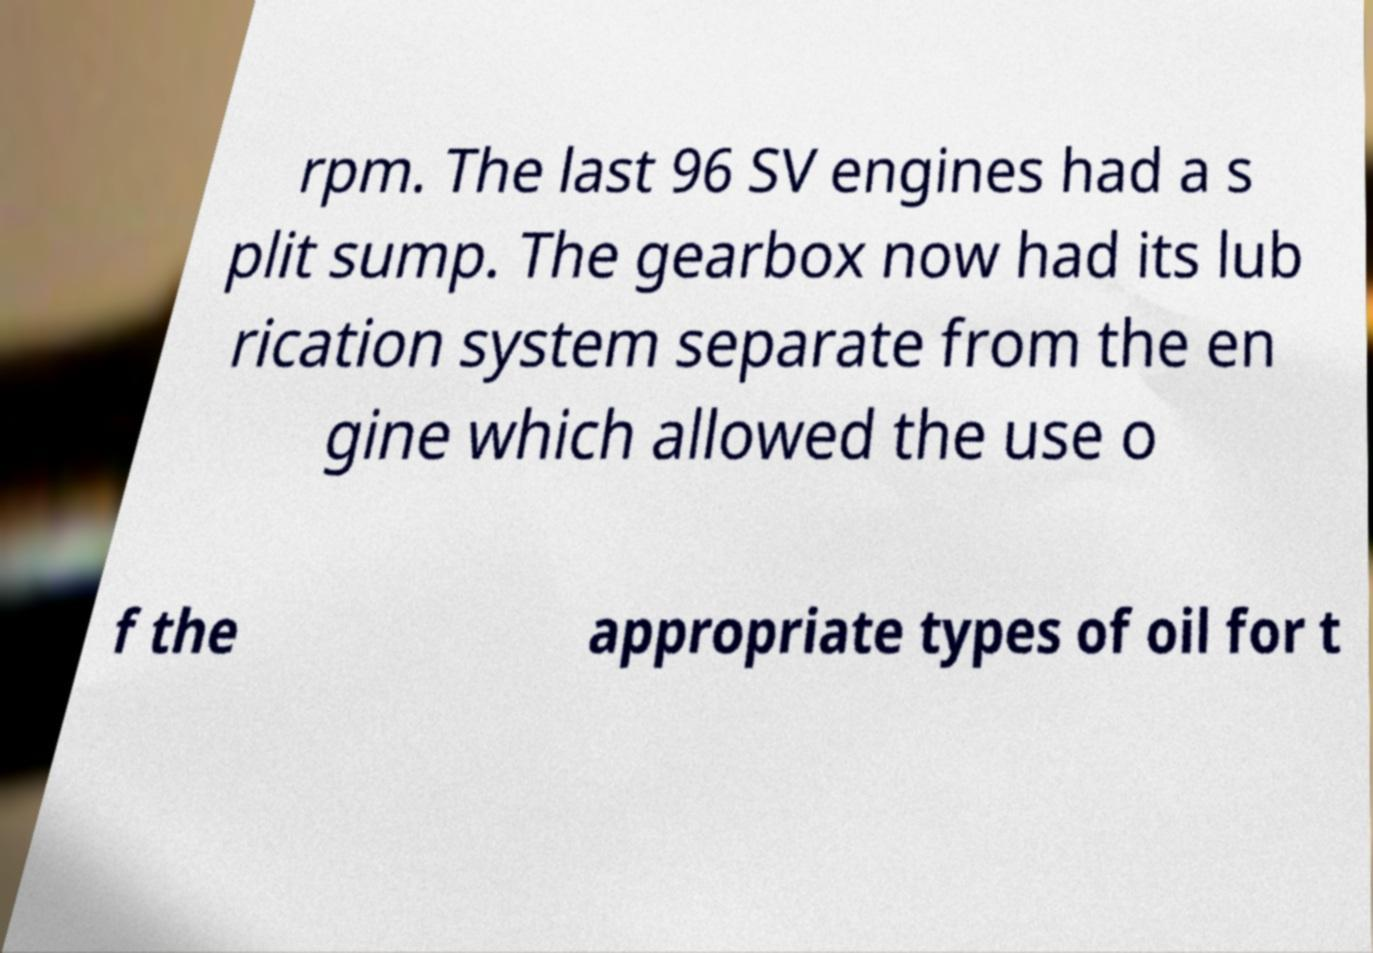Can you accurately transcribe the text from the provided image for me? rpm. The last 96 SV engines had a s plit sump. The gearbox now had its lub rication system separate from the en gine which allowed the use o f the appropriate types of oil for t 